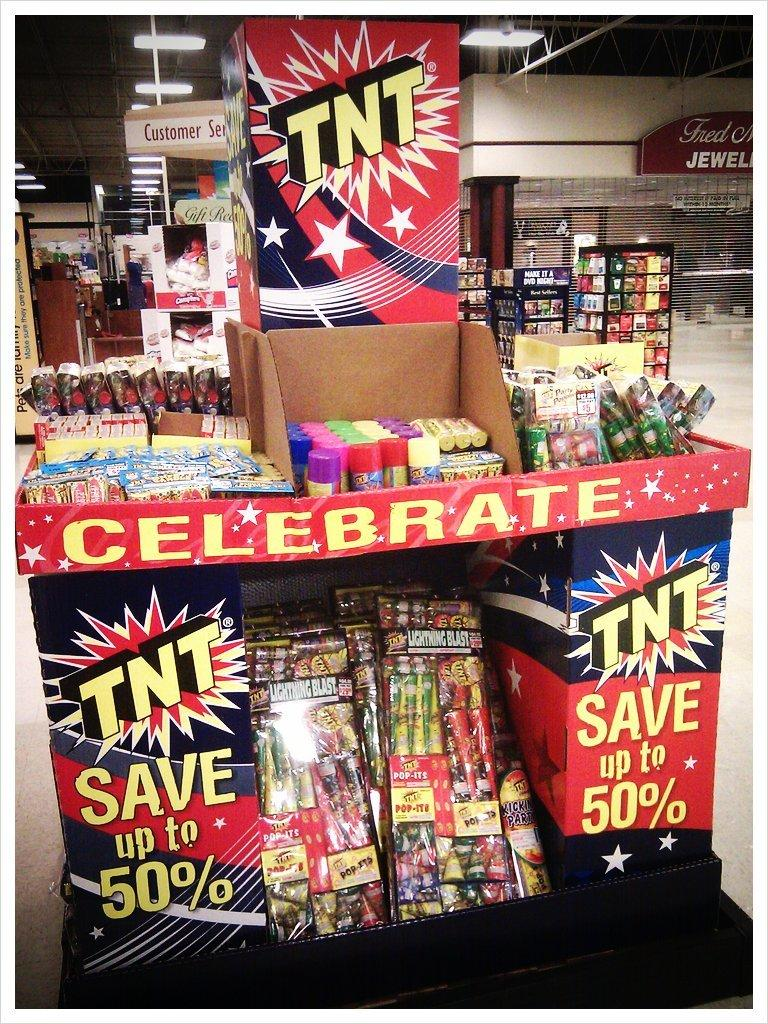<image>
Describe the image concisely. A display of TNT brand fireworks that states they are on sale. 